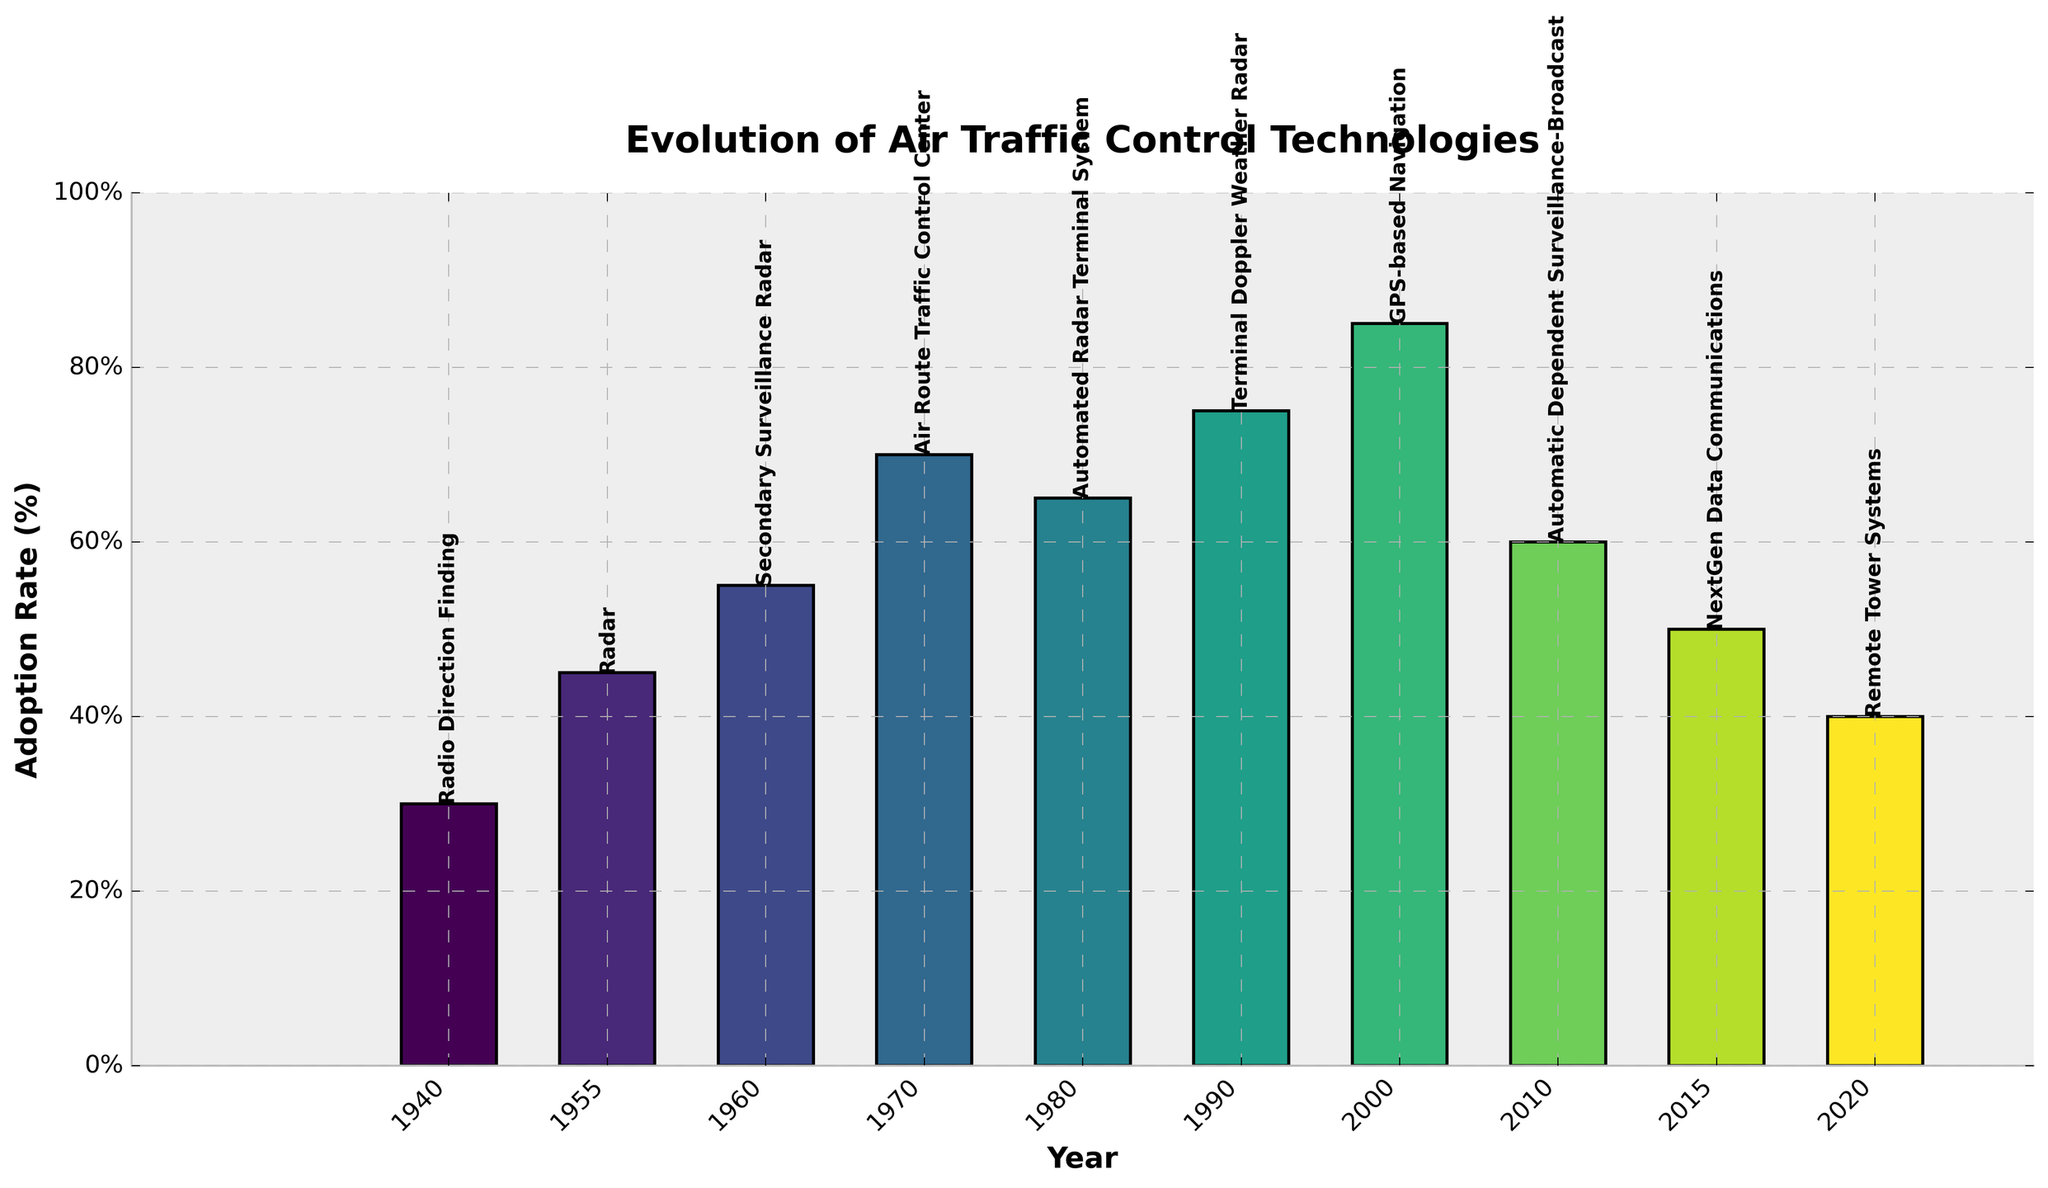Which technology had the highest adoption rate in 2000? Locate the bar corresponding to the year 2000 and find the technology label at the top. The adoption rate for the year 2000 is the highest for "GPS-based Navigation"
Answer: GPS-based Navigation Which year had the lowest adoption rate for air traffic control technology, and what was the technology adopted that year? Identify the shortest bar to find the year and the corresponding technology label. The shortest bar is for the year 1940 with the technology "Radio Direction Finding"
Answer: 1940, Radio Direction Finding How many years had an adoption rate above 60%? Count the number of bars with heights exceeding the 60% mark on the y-axis. The bars for 1955, 1960, 1970, 1980, 1990, and 2000 represent rates above 60%, making it 6 years in total
Answer: 6 Which year saw the largest drop in adoption rate compared to the previous technology, and by how much did it drop? Compare the adjacent bars to determine the largest decrease in height. The largest drop is between 2000 ("GPS-based Navigation" at 85%) and 2010 ("Automatic Dependent Surveillance-Broadcast" at 60%). The drop is 85% - 60% = 25%
Answer: 2010, 25% What is the difference in adoption rates between "Radar" and "Automatic Dependent Surveillance-Broadcast"? Find the bars for 1955 (Radar, 45%) and 2010 (Automatic Dependent Surveillance-Broadcast, 60%). Calculate the difference: 60% - 45% = 15%
Answer: 15% How many technologies had an adoption rate below 50%? Count the number of bars with heights below the 50% mark on the y-axis. The bars for 1940, 2015, and 2020 reflect rates below 50%, totaling 3
Answer: 3 What was the adoption rate for the technology introduced in 1990? Locate the bar for the year 1990 and read the height value to get the adoption rate. The adoption rate for the year 1990 is 75% for "Terminal Doppler Weather Radar"
Answer: 75% Which technology in the 1980s had an adoption rate and by how much? Locate the bar corresponding to the 1980s and determine the height and technology. The adoption rate in 1980 was 65% for "Automated Radar Terminal System"
Answer: 65% Which technology introduced in 2015 had what adoption rate? Find the bar for the year 2015 and determine the height and technology. The adoption rate in 2015 was 50% for "NextGen Data Communications"
Answer: 50% 